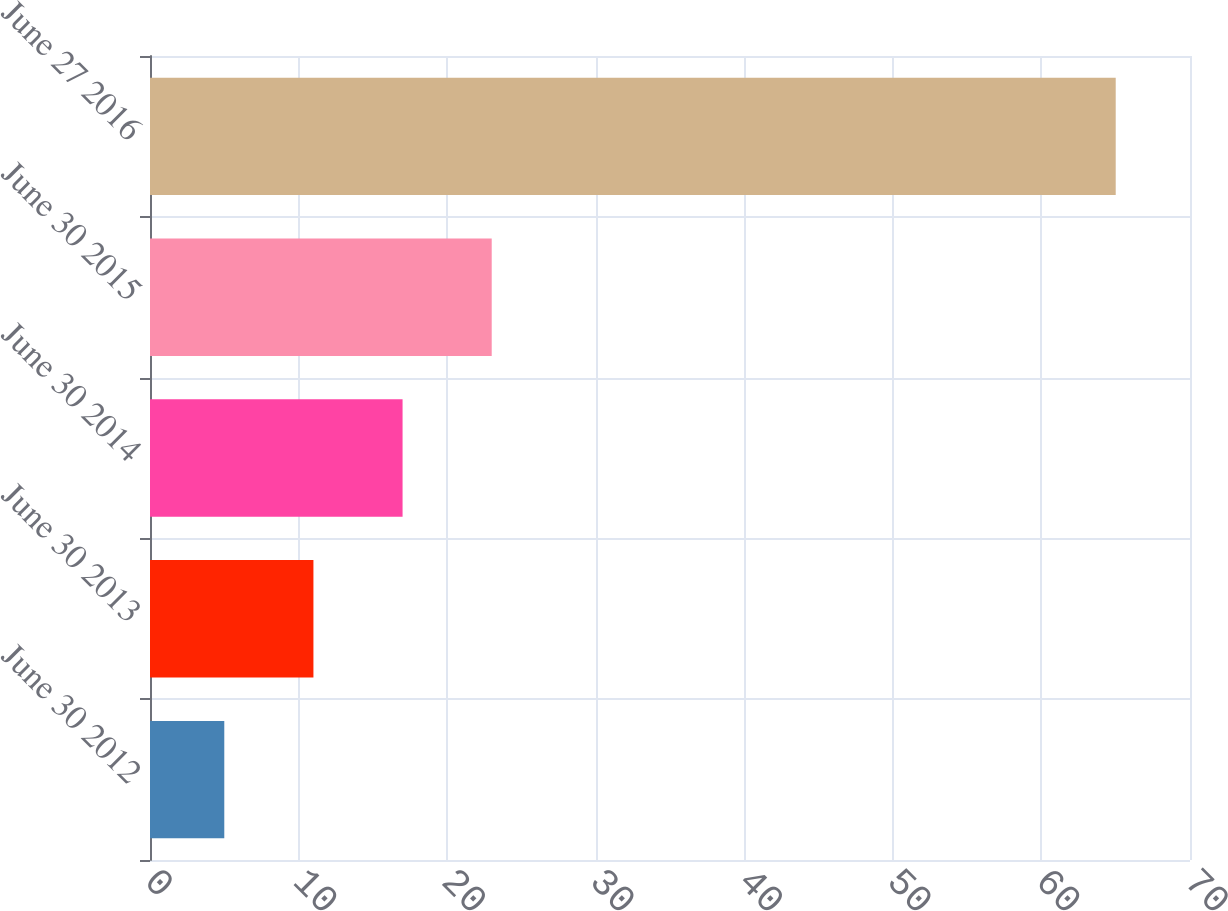<chart> <loc_0><loc_0><loc_500><loc_500><bar_chart><fcel>June 30 2012<fcel>June 30 2013<fcel>June 30 2014<fcel>June 30 2015<fcel>June 27 2016<nl><fcel>5<fcel>11<fcel>17<fcel>23<fcel>65<nl></chart> 